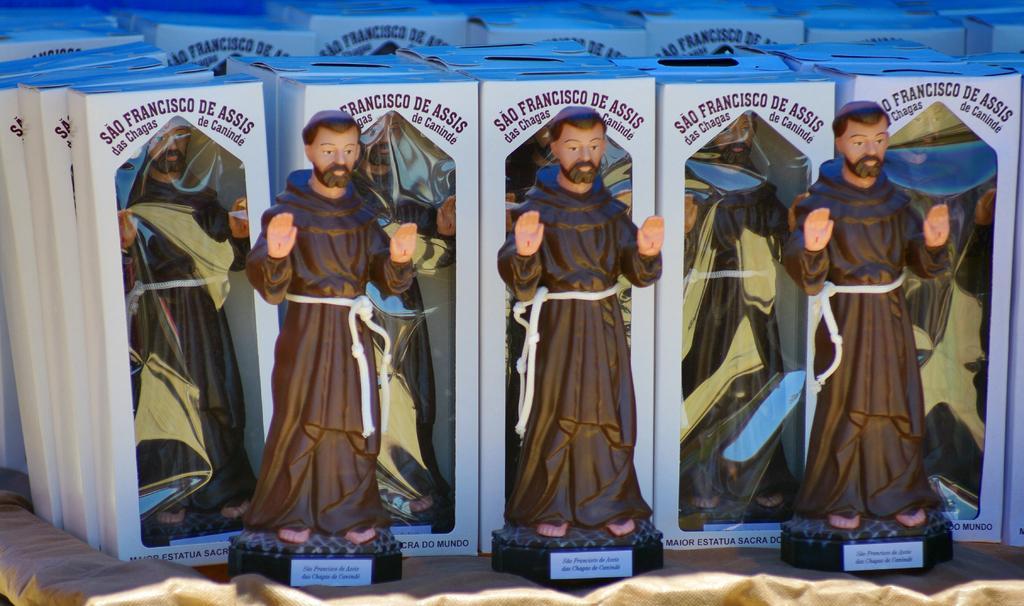How would you summarize this image in a sentence or two? In this image there is a cloth towards the bottom of the image, there are toys of a man, there is text on the toys, there are boxes, there is text on the boxes. 